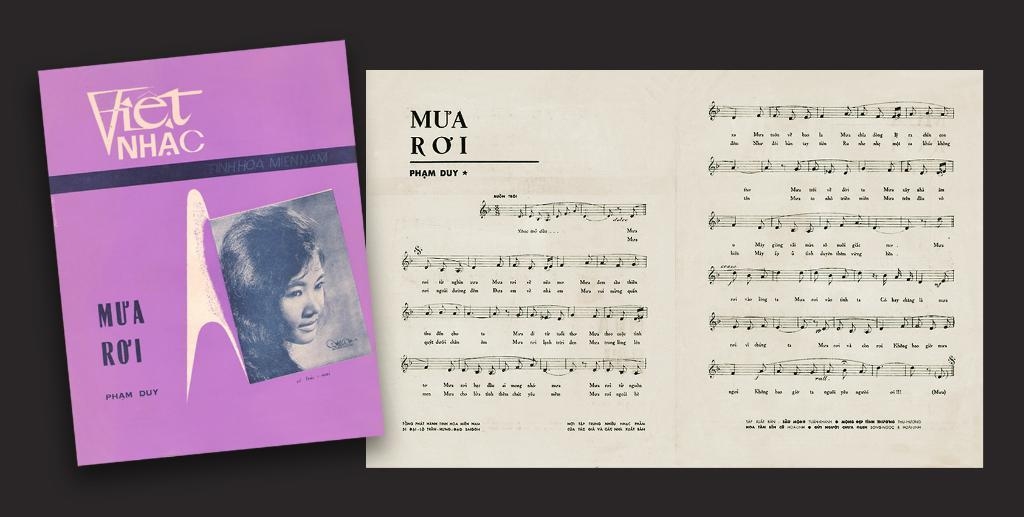What is depicted on the posts in the image? The posts have text and an image in the image. What can be observed about the overall color scheme of the image? The background of the image is dark. What type of leaf is being used to oil the posts in the image? There is no leaf or oil present in the image; it only features posts with text and an image against a dark background. 